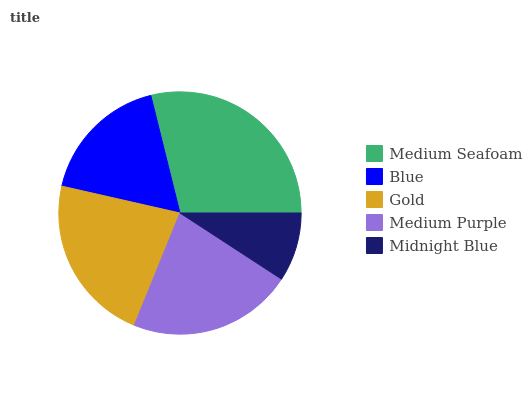Is Midnight Blue the minimum?
Answer yes or no. Yes. Is Medium Seafoam the maximum?
Answer yes or no. Yes. Is Blue the minimum?
Answer yes or no. No. Is Blue the maximum?
Answer yes or no. No. Is Medium Seafoam greater than Blue?
Answer yes or no. Yes. Is Blue less than Medium Seafoam?
Answer yes or no. Yes. Is Blue greater than Medium Seafoam?
Answer yes or no. No. Is Medium Seafoam less than Blue?
Answer yes or no. No. Is Medium Purple the high median?
Answer yes or no. Yes. Is Medium Purple the low median?
Answer yes or no. Yes. Is Blue the high median?
Answer yes or no. No. Is Midnight Blue the low median?
Answer yes or no. No. 